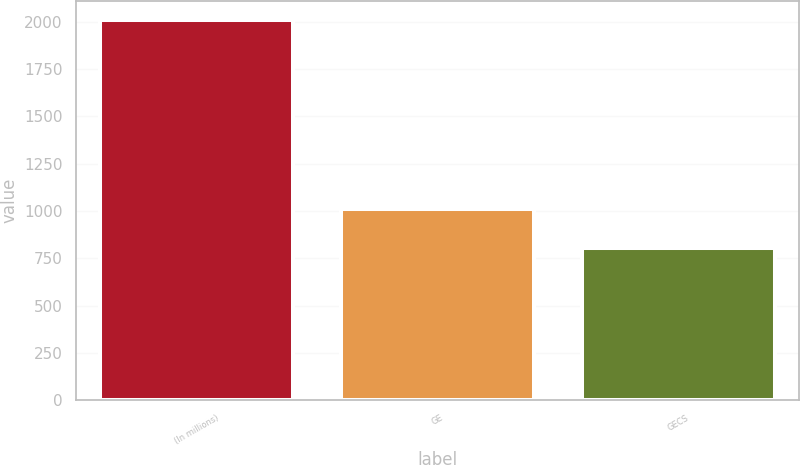<chart> <loc_0><loc_0><loc_500><loc_500><bar_chart><fcel>(In millions)<fcel>GE<fcel>GECS<nl><fcel>2009<fcel>1012<fcel>802<nl></chart> 